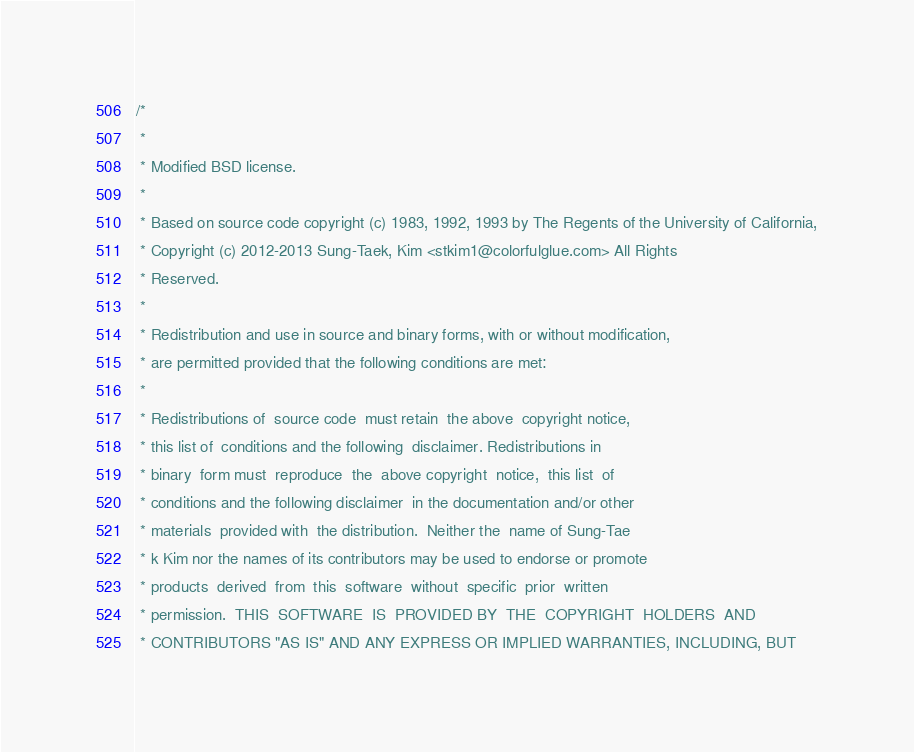<code> <loc_0><loc_0><loc_500><loc_500><_C_>/*
 *
 * Modified BSD license.
 * 
 * Based on source code copyright (c) 1983, 1992, 1993 by The Regents of the University of California,
 * Copyright (c) 2012-2013 Sung-Taek, Kim <stkim1@colorfulglue.com> All Rights
 * Reserved.
 *
 * Redistribution and use in source and binary forms, with or without modification,
 * are permitted provided that the following conditions are met:
 *
 * Redistributions of  source code  must retain  the above  copyright notice,
 * this list of  conditions and the following  disclaimer. Redistributions in
 * binary  form must  reproduce  the  above copyright  notice,  this list  of
 * conditions and the following disclaimer  in the documentation and/or other
 * materials  provided with  the distribution.  Neither the  name of Sung-Tae
 * k Kim nor the names of its contributors may be used to endorse or promote
 * products  derived  from  this  software  without  specific  prior  written
 * permission.  THIS  SOFTWARE  IS  PROVIDED BY  THE  COPYRIGHT  HOLDERS  AND
 * CONTRIBUTORS "AS IS" AND ANY EXPRESS OR IMPLIED WARRANTIES, INCLUDING, BUT</code> 